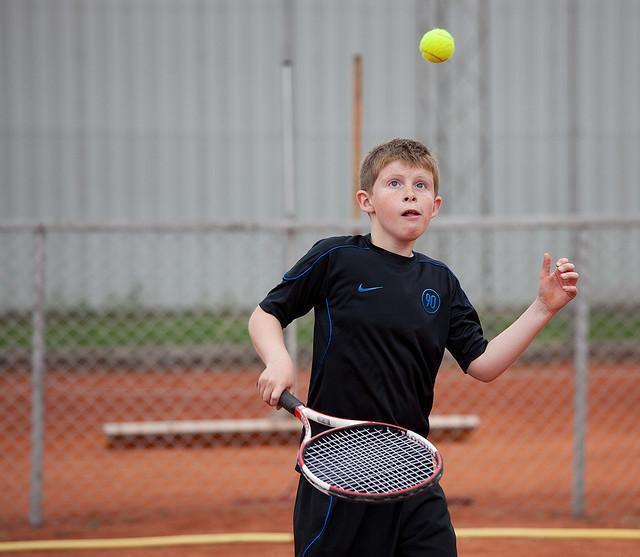What action will he take with the ball?
From the following four choices, select the correct answer to address the question.
Options: Roll, dunk, swing, dribble. Swing. 